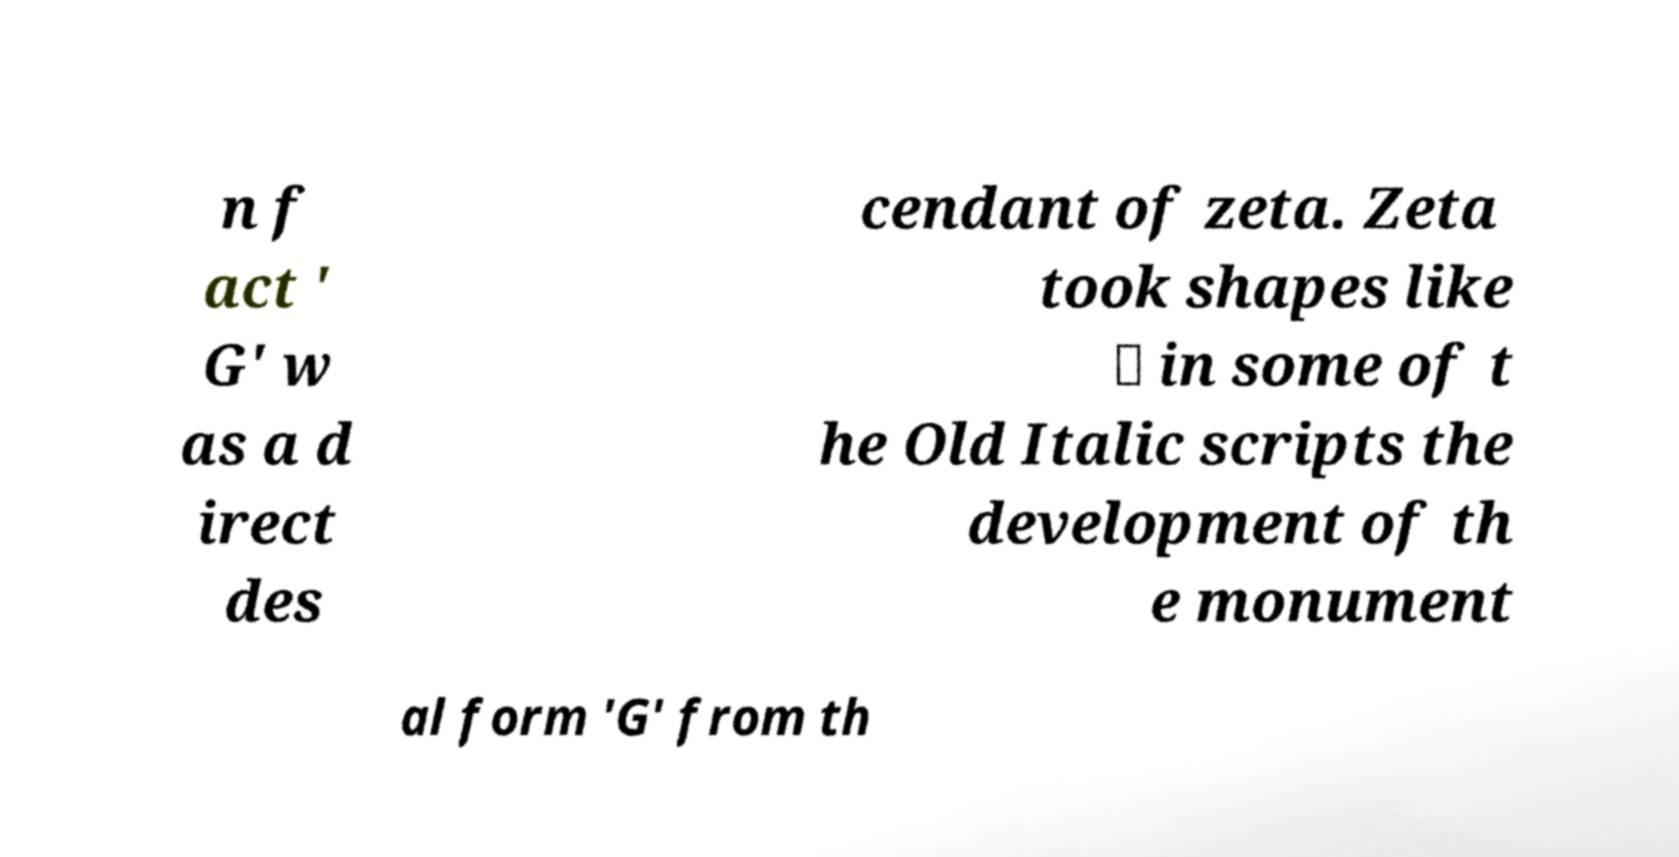I need the written content from this picture converted into text. Can you do that? n f act ' G' w as a d irect des cendant of zeta. Zeta took shapes like ⊏ in some of t he Old Italic scripts the development of th e monument al form 'G' from th 